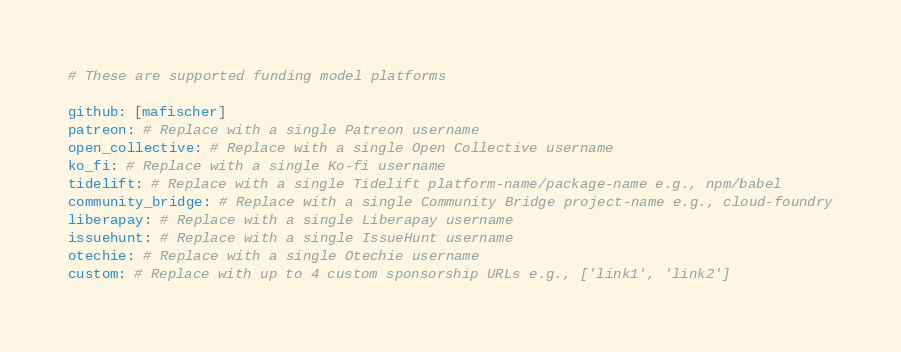<code> <loc_0><loc_0><loc_500><loc_500><_YAML_># These are supported funding model platforms

github: [mafischer]
patreon: # Replace with a single Patreon username
open_collective: # Replace with a single Open Collective username
ko_fi: # Replace with a single Ko-fi username
tidelift: # Replace with a single Tidelift platform-name/package-name e.g., npm/babel
community_bridge: # Replace with a single Community Bridge project-name e.g., cloud-foundry
liberapay: # Replace with a single Liberapay username
issuehunt: # Replace with a single IssueHunt username
otechie: # Replace with a single Otechie username
custom: # Replace with up to 4 custom sponsorship URLs e.g., ['link1', 'link2']
</code> 